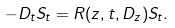Convert formula to latex. <formula><loc_0><loc_0><loc_500><loc_500>- D _ { t } S _ { t } = R ( z , t , D _ { z } ) S _ { t } .</formula> 